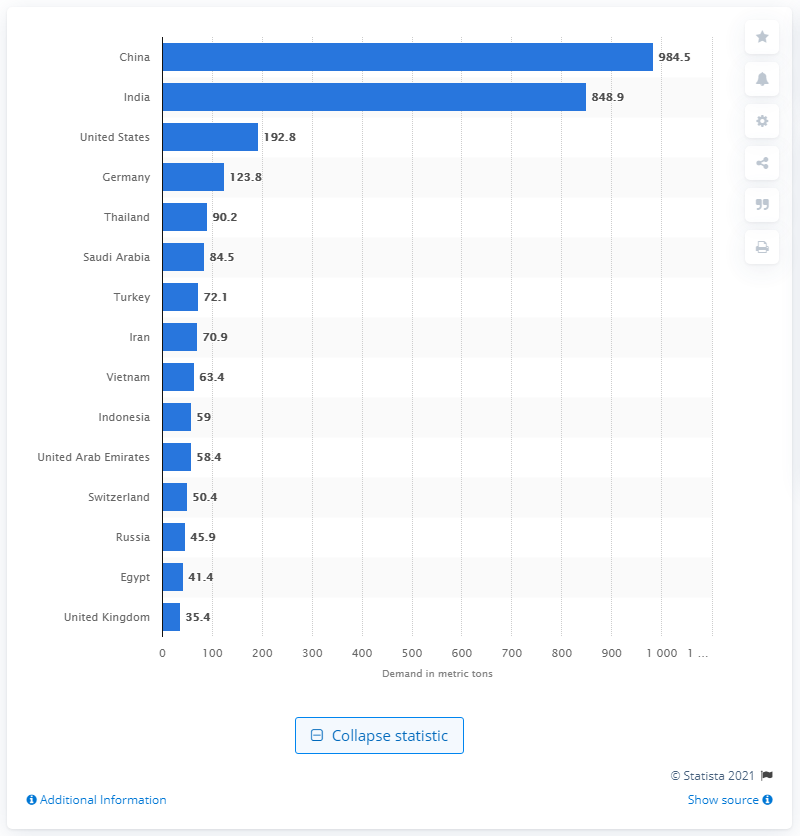Highlight a few significant elements in this photo. In 2015, China demanded 985 metric tons of gold for consumption. 